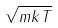Convert formula to latex. <formula><loc_0><loc_0><loc_500><loc_500>\sqrt { m k T }</formula> 